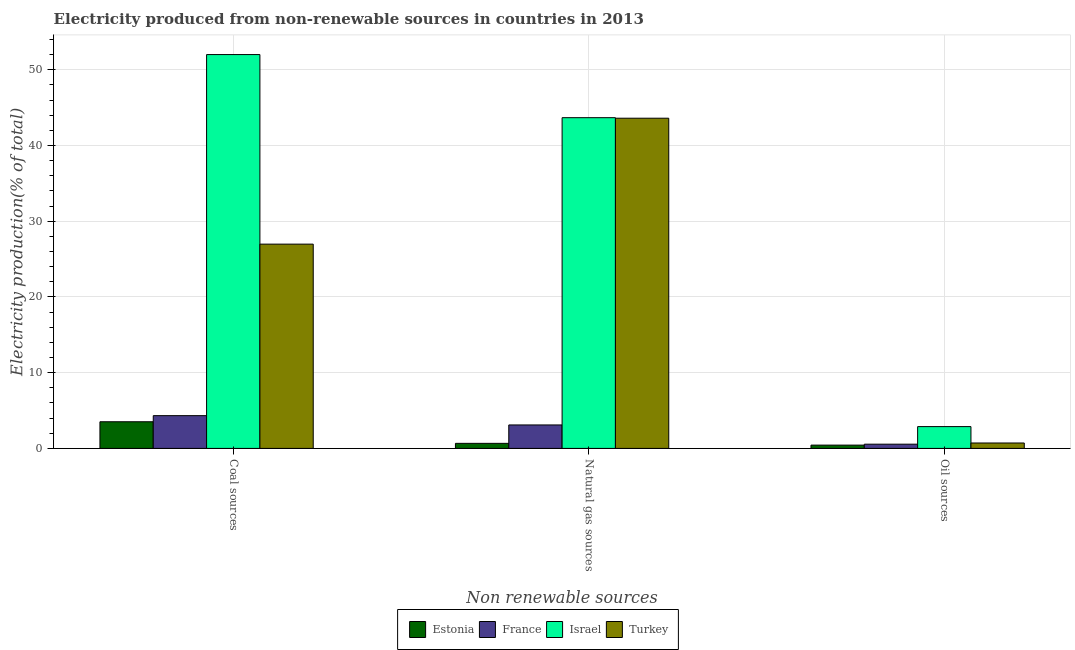How many different coloured bars are there?
Provide a succinct answer. 4. How many groups of bars are there?
Offer a terse response. 3. Are the number of bars per tick equal to the number of legend labels?
Ensure brevity in your answer.  Yes. Are the number of bars on each tick of the X-axis equal?
Offer a very short reply. Yes. How many bars are there on the 2nd tick from the right?
Make the answer very short. 4. What is the label of the 1st group of bars from the left?
Your answer should be very brief. Coal sources. What is the percentage of electricity produced by oil sources in Israel?
Keep it short and to the point. 2.88. Across all countries, what is the maximum percentage of electricity produced by coal?
Keep it short and to the point. 52.01. Across all countries, what is the minimum percentage of electricity produced by natural gas?
Provide a succinct answer. 0.67. In which country was the percentage of electricity produced by natural gas maximum?
Give a very brief answer. Israel. In which country was the percentage of electricity produced by natural gas minimum?
Keep it short and to the point. Estonia. What is the total percentage of electricity produced by natural gas in the graph?
Provide a short and direct response. 91.06. What is the difference between the percentage of electricity produced by oil sources in Estonia and that in Israel?
Your response must be concise. -2.45. What is the difference between the percentage of electricity produced by oil sources in France and the percentage of electricity produced by coal in Turkey?
Provide a short and direct response. -26.42. What is the average percentage of electricity produced by coal per country?
Make the answer very short. 21.71. What is the difference between the percentage of electricity produced by coal and percentage of electricity produced by oil sources in Estonia?
Make the answer very short. 3.08. In how many countries, is the percentage of electricity produced by oil sources greater than 18 %?
Provide a succinct answer. 0. What is the ratio of the percentage of electricity produced by coal in Turkey to that in Israel?
Give a very brief answer. 0.52. Is the percentage of electricity produced by coal in France less than that in Turkey?
Give a very brief answer. Yes. What is the difference between the highest and the second highest percentage of electricity produced by oil sources?
Provide a succinct answer. 2.17. What is the difference between the highest and the lowest percentage of electricity produced by coal?
Provide a succinct answer. 48.49. Is the sum of the percentage of electricity produced by coal in Estonia and France greater than the maximum percentage of electricity produced by natural gas across all countries?
Your response must be concise. No. What does the 2nd bar from the left in Oil sources represents?
Provide a short and direct response. France. What does the 4th bar from the right in Oil sources represents?
Your response must be concise. Estonia. How many bars are there?
Provide a short and direct response. 12. Are all the bars in the graph horizontal?
Make the answer very short. No. What is the difference between two consecutive major ticks on the Y-axis?
Your answer should be compact. 10. Does the graph contain any zero values?
Make the answer very short. No. Where does the legend appear in the graph?
Provide a short and direct response. Bottom center. How many legend labels are there?
Offer a terse response. 4. How are the legend labels stacked?
Make the answer very short. Horizontal. What is the title of the graph?
Your answer should be compact. Electricity produced from non-renewable sources in countries in 2013. What is the label or title of the X-axis?
Make the answer very short. Non renewable sources. What is the Electricity production(% of total) in Estonia in Coal sources?
Ensure brevity in your answer.  3.52. What is the Electricity production(% of total) in France in Coal sources?
Ensure brevity in your answer.  4.33. What is the Electricity production(% of total) of Israel in Coal sources?
Offer a very short reply. 52.01. What is the Electricity production(% of total) of Turkey in Coal sources?
Keep it short and to the point. 26.98. What is the Electricity production(% of total) of Estonia in Natural gas sources?
Provide a short and direct response. 0.67. What is the Electricity production(% of total) in France in Natural gas sources?
Provide a succinct answer. 3.1. What is the Electricity production(% of total) in Israel in Natural gas sources?
Offer a terse response. 43.68. What is the Electricity production(% of total) in Turkey in Natural gas sources?
Offer a very short reply. 43.61. What is the Electricity production(% of total) in Estonia in Oil sources?
Offer a very short reply. 0.44. What is the Electricity production(% of total) in France in Oil sources?
Offer a very short reply. 0.56. What is the Electricity production(% of total) in Israel in Oil sources?
Provide a short and direct response. 2.88. What is the Electricity production(% of total) of Turkey in Oil sources?
Make the answer very short. 0.72. Across all Non renewable sources, what is the maximum Electricity production(% of total) in Estonia?
Ensure brevity in your answer.  3.52. Across all Non renewable sources, what is the maximum Electricity production(% of total) in France?
Your answer should be very brief. 4.33. Across all Non renewable sources, what is the maximum Electricity production(% of total) of Israel?
Offer a terse response. 52.01. Across all Non renewable sources, what is the maximum Electricity production(% of total) in Turkey?
Your answer should be compact. 43.61. Across all Non renewable sources, what is the minimum Electricity production(% of total) of Estonia?
Offer a terse response. 0.44. Across all Non renewable sources, what is the minimum Electricity production(% of total) of France?
Make the answer very short. 0.56. Across all Non renewable sources, what is the minimum Electricity production(% of total) in Israel?
Your answer should be compact. 2.88. Across all Non renewable sources, what is the minimum Electricity production(% of total) in Turkey?
Your answer should be compact. 0.72. What is the total Electricity production(% of total) of Estonia in the graph?
Provide a succinct answer. 4.63. What is the total Electricity production(% of total) of France in the graph?
Your response must be concise. 7.99. What is the total Electricity production(% of total) in Israel in the graph?
Keep it short and to the point. 98.57. What is the total Electricity production(% of total) of Turkey in the graph?
Give a very brief answer. 71.3. What is the difference between the Electricity production(% of total) in Estonia in Coal sources and that in Natural gas sources?
Make the answer very short. 2.85. What is the difference between the Electricity production(% of total) of France in Coal sources and that in Natural gas sources?
Offer a very short reply. 1.23. What is the difference between the Electricity production(% of total) in Israel in Coal sources and that in Natural gas sources?
Make the answer very short. 8.34. What is the difference between the Electricity production(% of total) of Turkey in Coal sources and that in Natural gas sources?
Provide a succinct answer. -16.63. What is the difference between the Electricity production(% of total) in Estonia in Coal sources and that in Oil sources?
Provide a succinct answer. 3.08. What is the difference between the Electricity production(% of total) in France in Coal sources and that in Oil sources?
Offer a very short reply. 3.77. What is the difference between the Electricity production(% of total) of Israel in Coal sources and that in Oil sources?
Ensure brevity in your answer.  49.13. What is the difference between the Electricity production(% of total) of Turkey in Coal sources and that in Oil sources?
Ensure brevity in your answer.  26.26. What is the difference between the Electricity production(% of total) of Estonia in Natural gas sources and that in Oil sources?
Your answer should be very brief. 0.23. What is the difference between the Electricity production(% of total) of France in Natural gas sources and that in Oil sources?
Keep it short and to the point. 2.54. What is the difference between the Electricity production(% of total) in Israel in Natural gas sources and that in Oil sources?
Provide a short and direct response. 40.8. What is the difference between the Electricity production(% of total) of Turkey in Natural gas sources and that in Oil sources?
Ensure brevity in your answer.  42.89. What is the difference between the Electricity production(% of total) of Estonia in Coal sources and the Electricity production(% of total) of France in Natural gas sources?
Offer a very short reply. 0.42. What is the difference between the Electricity production(% of total) in Estonia in Coal sources and the Electricity production(% of total) in Israel in Natural gas sources?
Offer a very short reply. -40.16. What is the difference between the Electricity production(% of total) of Estonia in Coal sources and the Electricity production(% of total) of Turkey in Natural gas sources?
Ensure brevity in your answer.  -40.09. What is the difference between the Electricity production(% of total) of France in Coal sources and the Electricity production(% of total) of Israel in Natural gas sources?
Keep it short and to the point. -39.35. What is the difference between the Electricity production(% of total) of France in Coal sources and the Electricity production(% of total) of Turkey in Natural gas sources?
Provide a succinct answer. -39.28. What is the difference between the Electricity production(% of total) of Israel in Coal sources and the Electricity production(% of total) of Turkey in Natural gas sources?
Offer a very short reply. 8.41. What is the difference between the Electricity production(% of total) of Estonia in Coal sources and the Electricity production(% of total) of France in Oil sources?
Offer a terse response. 2.96. What is the difference between the Electricity production(% of total) in Estonia in Coal sources and the Electricity production(% of total) in Israel in Oil sources?
Offer a very short reply. 0.64. What is the difference between the Electricity production(% of total) in Estonia in Coal sources and the Electricity production(% of total) in Turkey in Oil sources?
Ensure brevity in your answer.  2.81. What is the difference between the Electricity production(% of total) in France in Coal sources and the Electricity production(% of total) in Israel in Oil sources?
Keep it short and to the point. 1.45. What is the difference between the Electricity production(% of total) in France in Coal sources and the Electricity production(% of total) in Turkey in Oil sources?
Your answer should be compact. 3.61. What is the difference between the Electricity production(% of total) of Israel in Coal sources and the Electricity production(% of total) of Turkey in Oil sources?
Offer a terse response. 51.3. What is the difference between the Electricity production(% of total) of Estonia in Natural gas sources and the Electricity production(% of total) of France in Oil sources?
Offer a terse response. 0.11. What is the difference between the Electricity production(% of total) of Estonia in Natural gas sources and the Electricity production(% of total) of Israel in Oil sources?
Offer a terse response. -2.21. What is the difference between the Electricity production(% of total) of Estonia in Natural gas sources and the Electricity production(% of total) of Turkey in Oil sources?
Your answer should be very brief. -0.05. What is the difference between the Electricity production(% of total) of France in Natural gas sources and the Electricity production(% of total) of Israel in Oil sources?
Your response must be concise. 0.22. What is the difference between the Electricity production(% of total) in France in Natural gas sources and the Electricity production(% of total) in Turkey in Oil sources?
Offer a very short reply. 2.38. What is the difference between the Electricity production(% of total) in Israel in Natural gas sources and the Electricity production(% of total) in Turkey in Oil sources?
Offer a terse response. 42.96. What is the average Electricity production(% of total) in Estonia per Non renewable sources?
Make the answer very short. 1.54. What is the average Electricity production(% of total) of France per Non renewable sources?
Provide a short and direct response. 2.66. What is the average Electricity production(% of total) of Israel per Non renewable sources?
Your answer should be compact. 32.86. What is the average Electricity production(% of total) of Turkey per Non renewable sources?
Provide a succinct answer. 23.77. What is the difference between the Electricity production(% of total) in Estonia and Electricity production(% of total) in France in Coal sources?
Your response must be concise. -0.81. What is the difference between the Electricity production(% of total) in Estonia and Electricity production(% of total) in Israel in Coal sources?
Offer a very short reply. -48.49. What is the difference between the Electricity production(% of total) of Estonia and Electricity production(% of total) of Turkey in Coal sources?
Make the answer very short. -23.46. What is the difference between the Electricity production(% of total) in France and Electricity production(% of total) in Israel in Coal sources?
Your answer should be very brief. -47.69. What is the difference between the Electricity production(% of total) of France and Electricity production(% of total) of Turkey in Coal sources?
Offer a terse response. -22.65. What is the difference between the Electricity production(% of total) of Israel and Electricity production(% of total) of Turkey in Coal sources?
Your response must be concise. 25.04. What is the difference between the Electricity production(% of total) in Estonia and Electricity production(% of total) in France in Natural gas sources?
Give a very brief answer. -2.43. What is the difference between the Electricity production(% of total) of Estonia and Electricity production(% of total) of Israel in Natural gas sources?
Offer a terse response. -43.01. What is the difference between the Electricity production(% of total) in Estonia and Electricity production(% of total) in Turkey in Natural gas sources?
Give a very brief answer. -42.94. What is the difference between the Electricity production(% of total) in France and Electricity production(% of total) in Israel in Natural gas sources?
Keep it short and to the point. -40.58. What is the difference between the Electricity production(% of total) of France and Electricity production(% of total) of Turkey in Natural gas sources?
Provide a short and direct response. -40.51. What is the difference between the Electricity production(% of total) of Israel and Electricity production(% of total) of Turkey in Natural gas sources?
Your response must be concise. 0.07. What is the difference between the Electricity production(% of total) in Estonia and Electricity production(% of total) in France in Oil sources?
Your response must be concise. -0.12. What is the difference between the Electricity production(% of total) in Estonia and Electricity production(% of total) in Israel in Oil sources?
Offer a terse response. -2.45. What is the difference between the Electricity production(% of total) of Estonia and Electricity production(% of total) of Turkey in Oil sources?
Your answer should be very brief. -0.28. What is the difference between the Electricity production(% of total) in France and Electricity production(% of total) in Israel in Oil sources?
Your response must be concise. -2.32. What is the difference between the Electricity production(% of total) of France and Electricity production(% of total) of Turkey in Oil sources?
Make the answer very short. -0.16. What is the difference between the Electricity production(% of total) in Israel and Electricity production(% of total) in Turkey in Oil sources?
Give a very brief answer. 2.17. What is the ratio of the Electricity production(% of total) in Estonia in Coal sources to that in Natural gas sources?
Your answer should be very brief. 5.26. What is the ratio of the Electricity production(% of total) of France in Coal sources to that in Natural gas sources?
Your answer should be compact. 1.4. What is the ratio of the Electricity production(% of total) in Israel in Coal sources to that in Natural gas sources?
Your answer should be compact. 1.19. What is the ratio of the Electricity production(% of total) in Turkey in Coal sources to that in Natural gas sources?
Give a very brief answer. 0.62. What is the ratio of the Electricity production(% of total) of Estonia in Coal sources to that in Oil sources?
Ensure brevity in your answer.  8.07. What is the ratio of the Electricity production(% of total) in France in Coal sources to that in Oil sources?
Your answer should be very brief. 7.72. What is the ratio of the Electricity production(% of total) in Israel in Coal sources to that in Oil sources?
Your answer should be compact. 18.05. What is the ratio of the Electricity production(% of total) of Turkey in Coal sources to that in Oil sources?
Your answer should be compact. 37.67. What is the ratio of the Electricity production(% of total) in Estonia in Natural gas sources to that in Oil sources?
Give a very brief answer. 1.53. What is the ratio of the Electricity production(% of total) in France in Natural gas sources to that in Oil sources?
Ensure brevity in your answer.  5.53. What is the ratio of the Electricity production(% of total) in Israel in Natural gas sources to that in Oil sources?
Give a very brief answer. 15.16. What is the ratio of the Electricity production(% of total) of Turkey in Natural gas sources to that in Oil sources?
Offer a terse response. 60.89. What is the difference between the highest and the second highest Electricity production(% of total) of Estonia?
Give a very brief answer. 2.85. What is the difference between the highest and the second highest Electricity production(% of total) in France?
Your answer should be compact. 1.23. What is the difference between the highest and the second highest Electricity production(% of total) in Israel?
Offer a very short reply. 8.34. What is the difference between the highest and the second highest Electricity production(% of total) of Turkey?
Your response must be concise. 16.63. What is the difference between the highest and the lowest Electricity production(% of total) of Estonia?
Your response must be concise. 3.08. What is the difference between the highest and the lowest Electricity production(% of total) of France?
Provide a short and direct response. 3.77. What is the difference between the highest and the lowest Electricity production(% of total) in Israel?
Your answer should be compact. 49.13. What is the difference between the highest and the lowest Electricity production(% of total) of Turkey?
Keep it short and to the point. 42.89. 